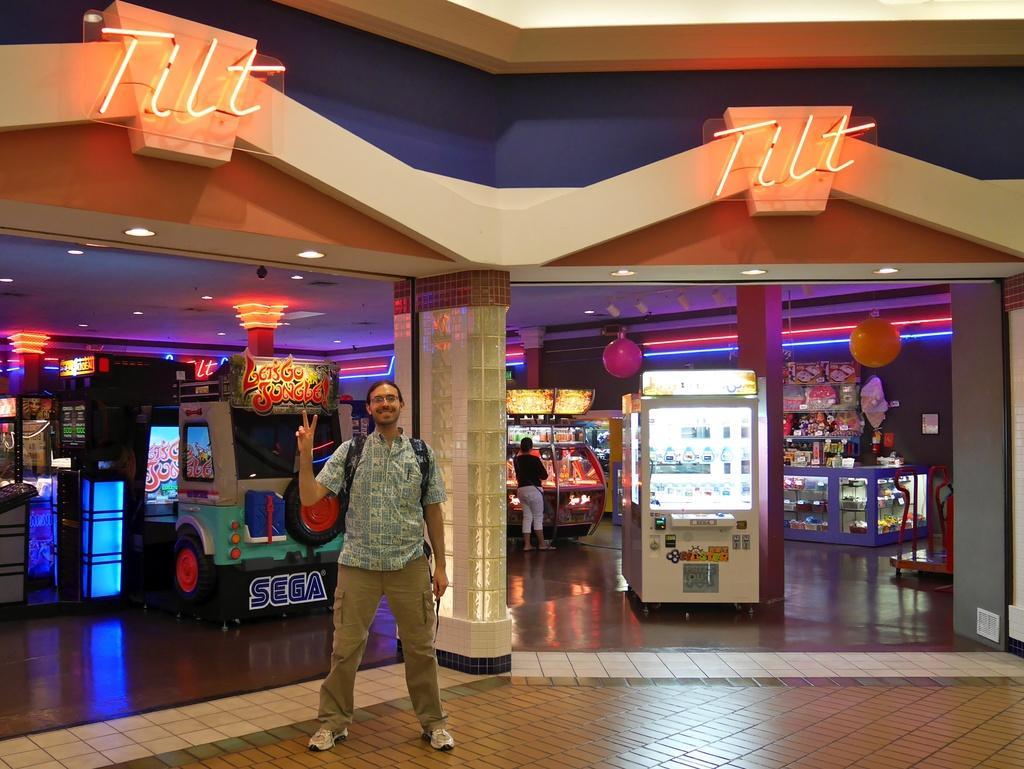Could you give a brief overview of what you see in this image? In this picture we can see there are two people standing on the floor. Behind the people there is a pillar, some machines, a wall and some objects. At the top there are name boards and ceiling lights. 